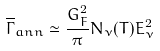Convert formula to latex. <formula><loc_0><loc_0><loc_500><loc_500>\overline { \Gamma } _ { a n n } \simeq \frac { G _ { F } ^ { 2 } } { \pi } N _ { \nu } ( T ) E _ { \nu } ^ { 2 }</formula> 